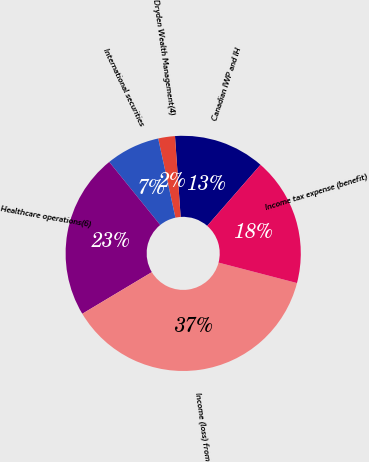Convert chart to OTSL. <chart><loc_0><loc_0><loc_500><loc_500><pie_chart><fcel>Canadian IWP and IH<fcel>Dryden Wealth Management(4)<fcel>International securities<fcel>Healthcare operations(6)<fcel>Income (loss) from<fcel>Income tax expense (benefit)<nl><fcel>12.53%<fcel>2.3%<fcel>7.41%<fcel>22.76%<fcel>37.36%<fcel>17.64%<nl></chart> 